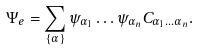Convert formula to latex. <formula><loc_0><loc_0><loc_500><loc_500>\Psi _ { e } = \sum _ { \{ \alpha \} } \psi _ { \alpha _ { 1 } } \dots \psi _ { \alpha _ { n } } C _ { \alpha _ { 1 } \dots \alpha _ { n } } .</formula> 